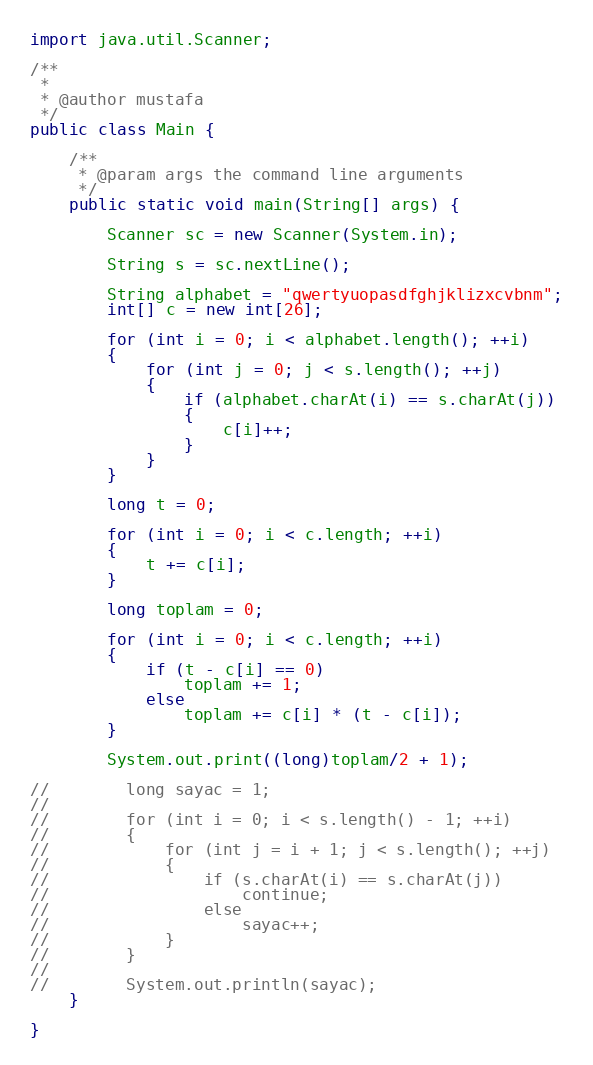<code> <loc_0><loc_0><loc_500><loc_500><_Java_>import java.util.Scanner;

/**
 *
 * @author mustafa
 */
public class Main {

    /**
     * @param args the command line arguments
     */
    public static void main(String[] args) {
        
        Scanner sc = new Scanner(System.in);
        
        String s = sc.nextLine();
        
        String alphabet = "qwertyuopasdfghjklizxcvbnm";
        int[] c = new int[26];
        
        for (int i = 0; i < alphabet.length(); ++i)
        {
            for (int j = 0; j < s.length(); ++j)
            {
                if (alphabet.charAt(i) == s.charAt(j))
                {
                    c[i]++;
                }
            }
        }
        
        long t = 0;
        
        for (int i = 0; i < c.length; ++i)
        {
            t += c[i];
        }
        
        long toplam = 0;
        
        for (int i = 0; i < c.length; ++i)
        {
            if (t - c[i] == 0)
                toplam += 1;
            else
                toplam += c[i] * (t - c[i]);
        }
        
        System.out.print((long)toplam/2 + 1);
        
//        long sayac = 1;
//        
//        for (int i = 0; i < s.length() - 1; ++i)
//        {
//            for (int j = i + 1; j < s.length(); ++j)
//            {
//                if (s.charAt(i) == s.charAt(j))
//                    continue;
//                else
//                    sayac++;
//            }
//        }
//        
//        System.out.println(sayac);
    }
    
}</code> 